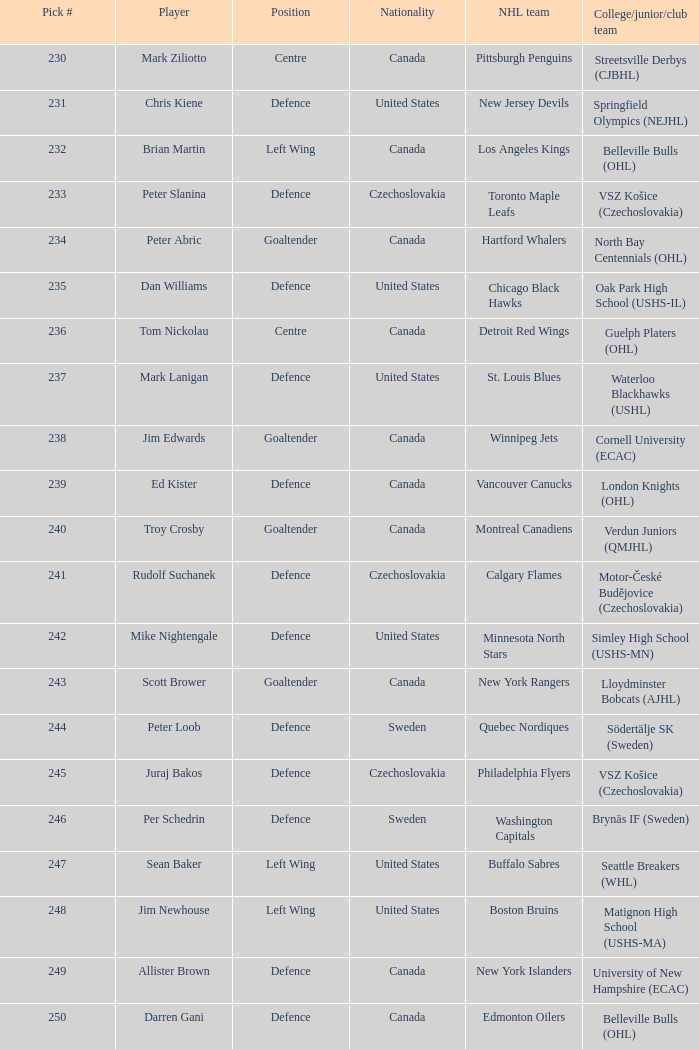What choice was the springfield olympics (nejhl)? 231.0. 